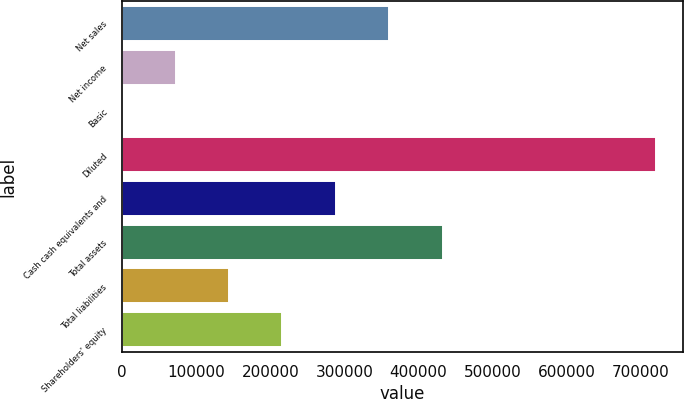Convert chart to OTSL. <chart><loc_0><loc_0><loc_500><loc_500><bar_chart><fcel>Net sales<fcel>Net income<fcel>Basic<fcel>Diluted<fcel>Cash cash equivalents and<fcel>Total assets<fcel>Total liabilities<fcel>Shareholders' equity<nl><fcel>360723<fcel>72144.6<fcel>0.06<fcel>721445<fcel>288578<fcel>432867<fcel>144289<fcel>216434<nl></chart> 